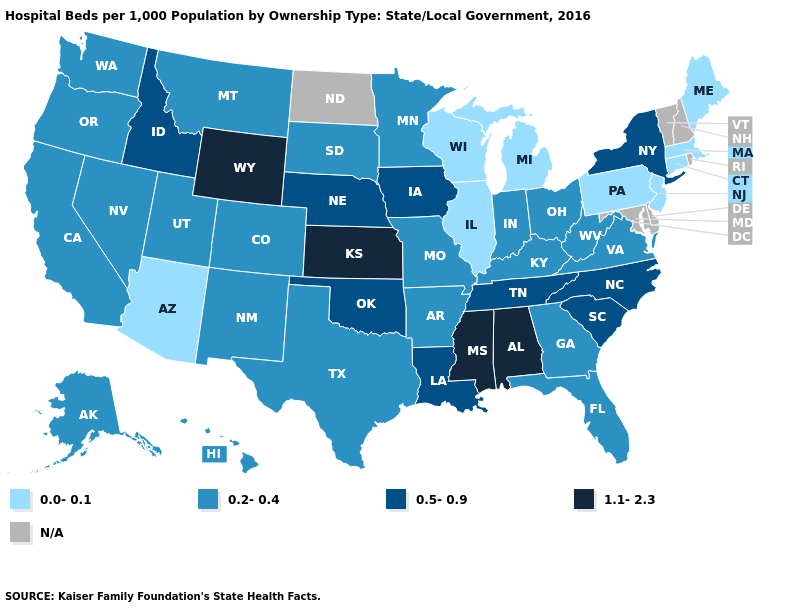Does Wyoming have the highest value in the USA?
Concise answer only. Yes. Among the states that border Virginia , which have the lowest value?
Write a very short answer. Kentucky, West Virginia. Name the states that have a value in the range 0.2-0.4?
Answer briefly. Alaska, Arkansas, California, Colorado, Florida, Georgia, Hawaii, Indiana, Kentucky, Minnesota, Missouri, Montana, Nevada, New Mexico, Ohio, Oregon, South Dakota, Texas, Utah, Virginia, Washington, West Virginia. Name the states that have a value in the range N/A?
Keep it brief. Delaware, Maryland, New Hampshire, North Dakota, Rhode Island, Vermont. What is the value of Oklahoma?
Answer briefly. 0.5-0.9. How many symbols are there in the legend?
Write a very short answer. 5. Which states have the lowest value in the USA?
Be succinct. Arizona, Connecticut, Illinois, Maine, Massachusetts, Michigan, New Jersey, Pennsylvania, Wisconsin. Which states have the highest value in the USA?
Concise answer only. Alabama, Kansas, Mississippi, Wyoming. What is the value of Montana?
Answer briefly. 0.2-0.4. Which states have the highest value in the USA?
Keep it brief. Alabama, Kansas, Mississippi, Wyoming. Among the states that border Vermont , does New York have the highest value?
Short answer required. Yes. 